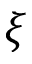Convert formula to latex. <formula><loc_0><loc_0><loc_500><loc_500>\xi</formula> 